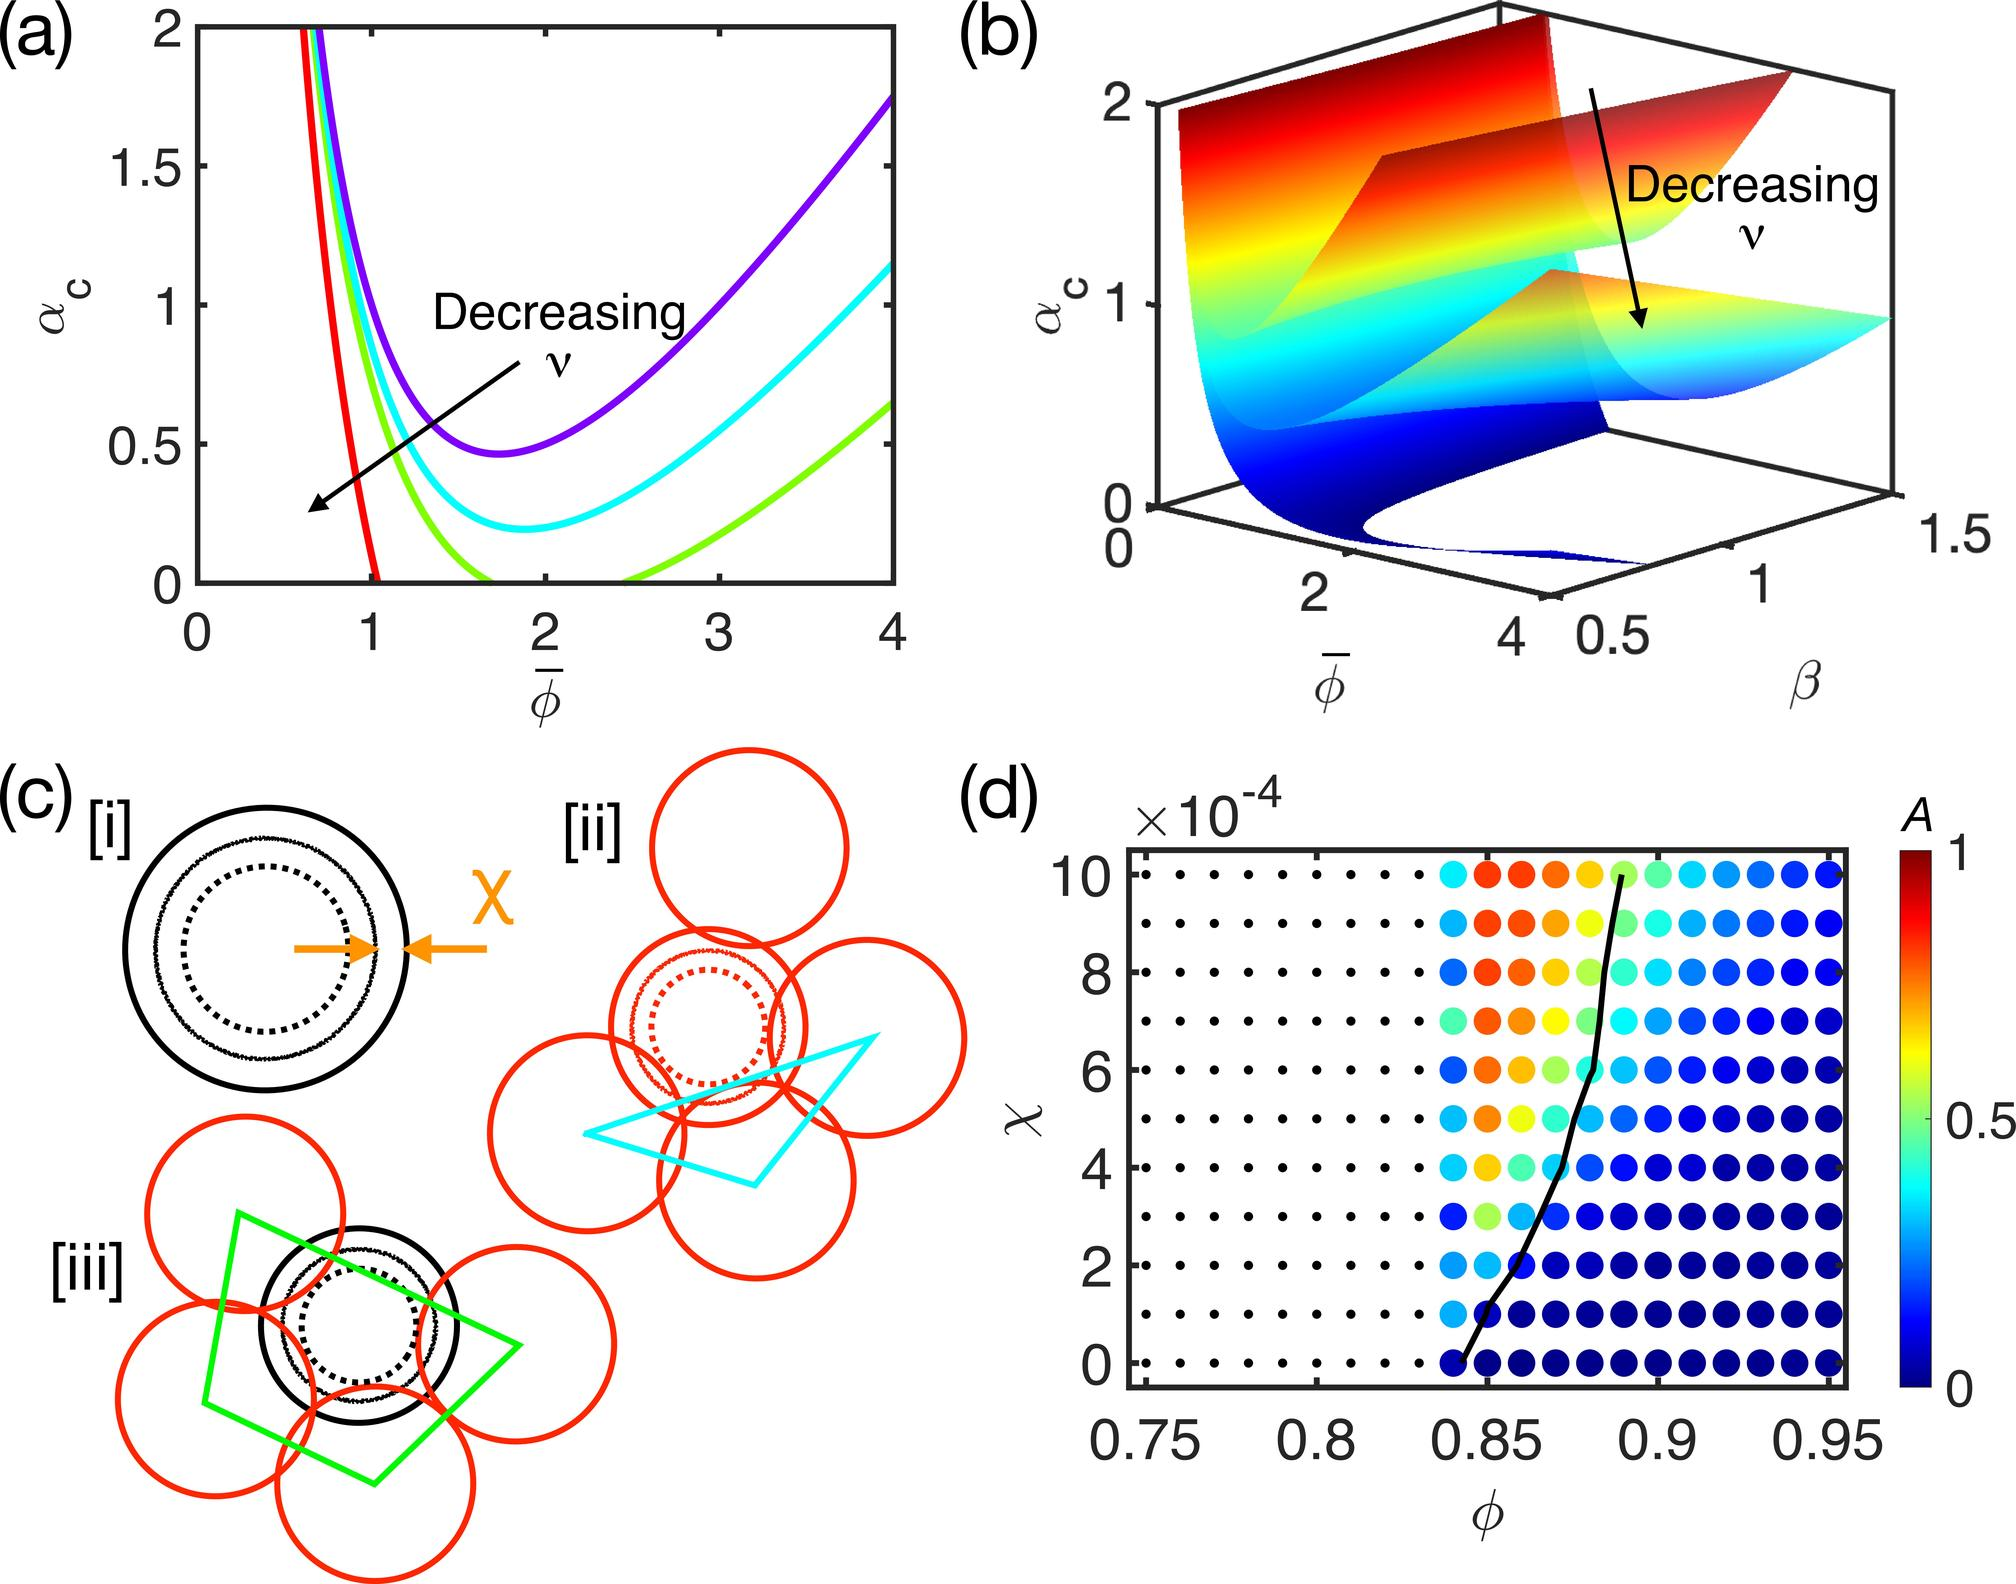What trend is indicated by the color gradient in relation to the variable φ? A. A is proportional to φ B. A is inversely proportional to φ C. A has no correlation with φ D. A has a complex relationship with φ, showing regions of both direct and inverse proportionality The color gradient changes from warm to cool as φ increases, suggesting regions where A is higher at lower φ and lower at higher φ, indicating a complex relationship rather than a simple direct or inverse proportionality. Therefore, the correct answer is D. 